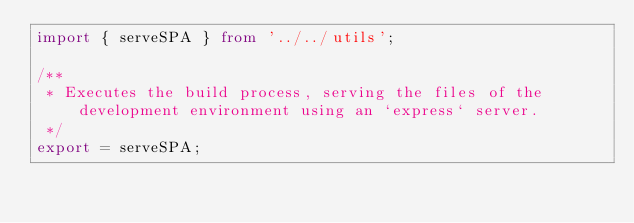Convert code to text. <code><loc_0><loc_0><loc_500><loc_500><_TypeScript_>import { serveSPA } from '../../utils';

/**
 * Executes the build process, serving the files of the development environment using an `express` server.
 */
export = serveSPA;
</code> 